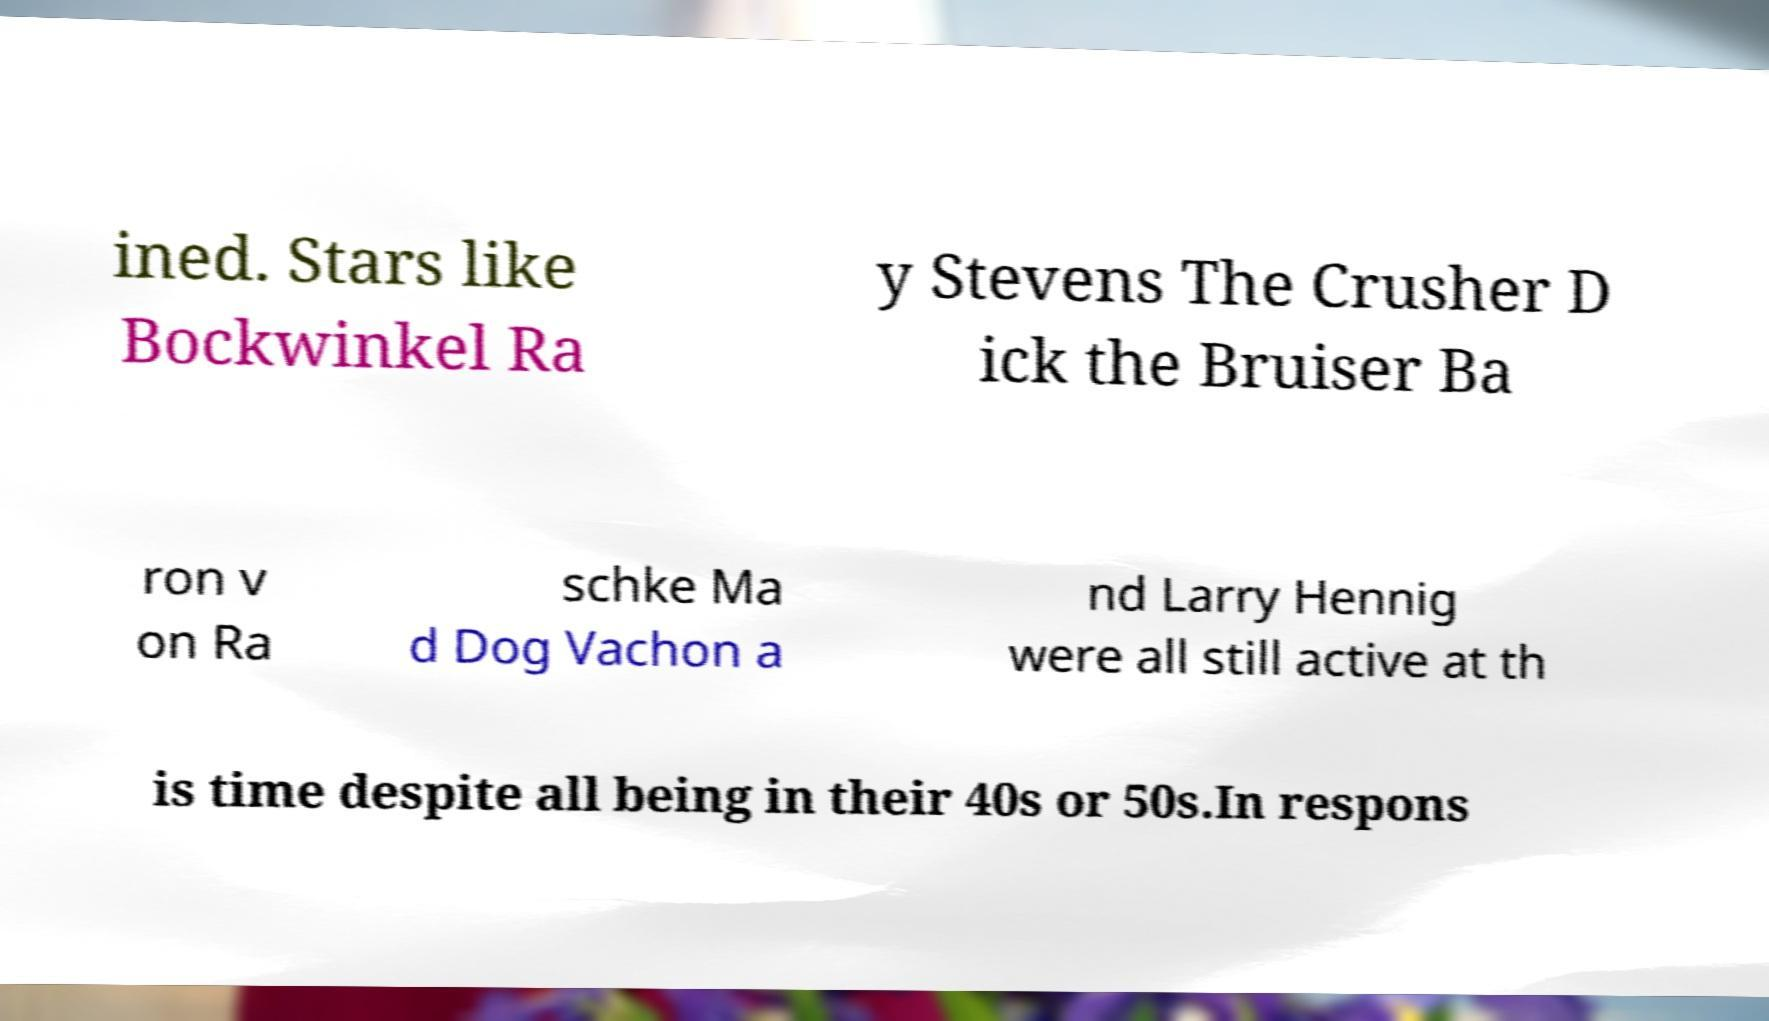I need the written content from this picture converted into text. Can you do that? ined. Stars like Bockwinkel Ra y Stevens The Crusher D ick the Bruiser Ba ron v on Ra schke Ma d Dog Vachon a nd Larry Hennig were all still active at th is time despite all being in their 40s or 50s.In respons 